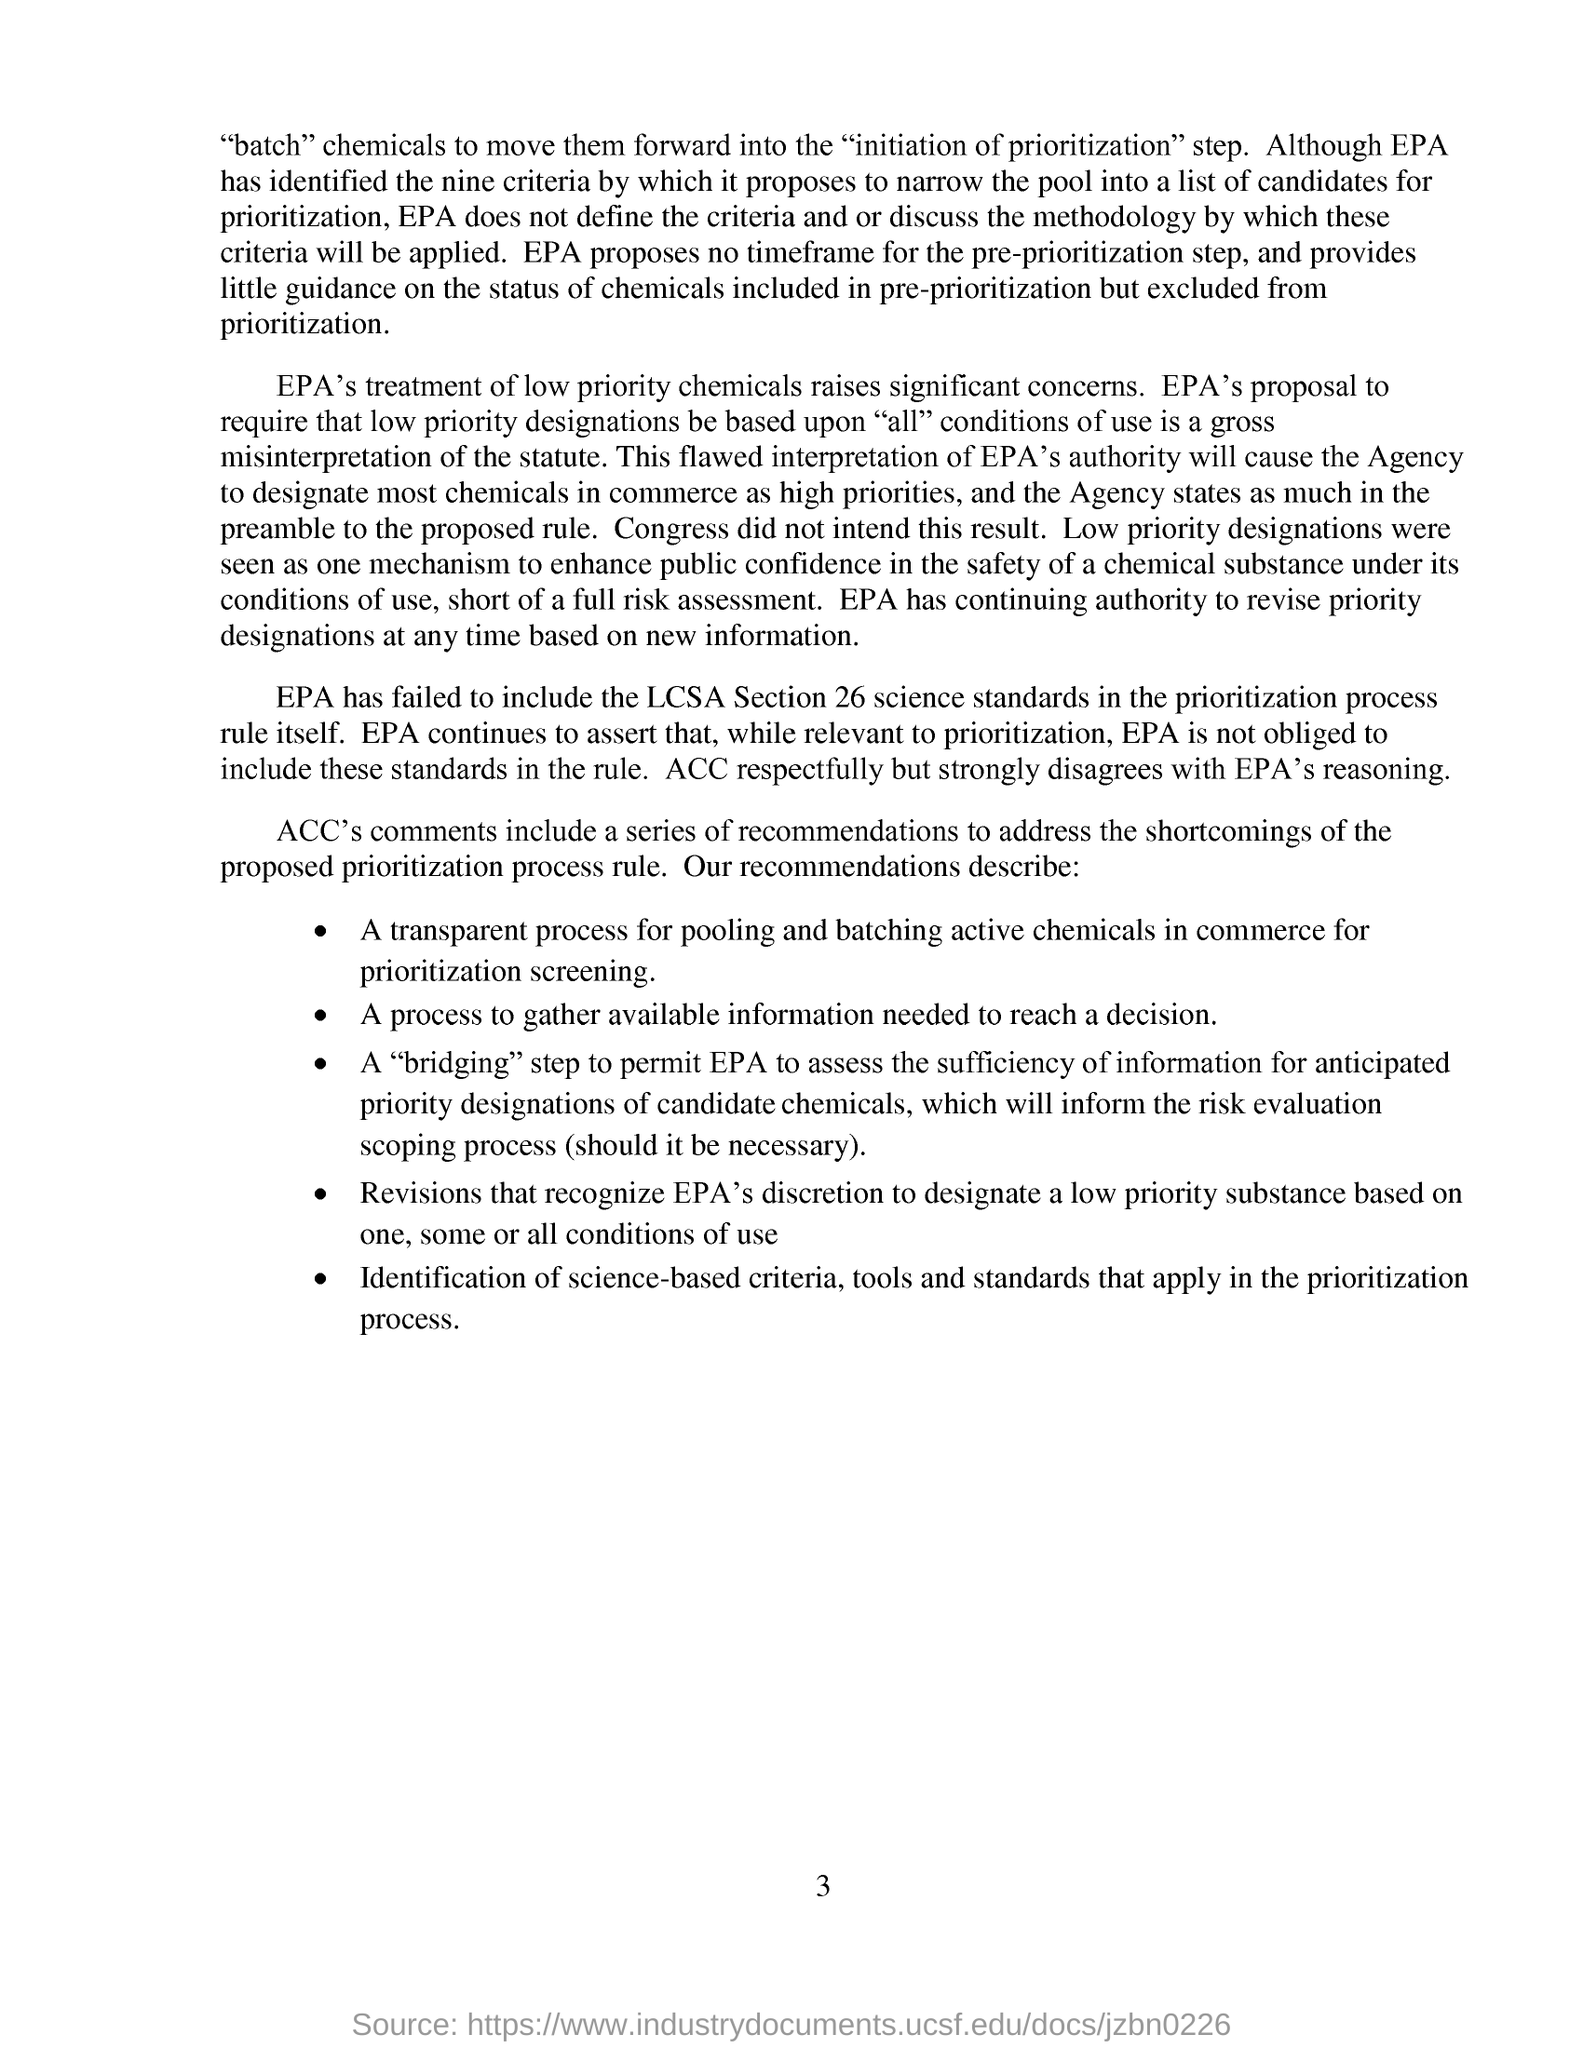List a handful of essential elements in this visual. According to the provided source, the Environmental Protection Agency has not included Section 26 of the Lead Contamination in Children's Products (Lead Content and Related Prohibitions) Regulations 2011 (LCSAs) in their report. 